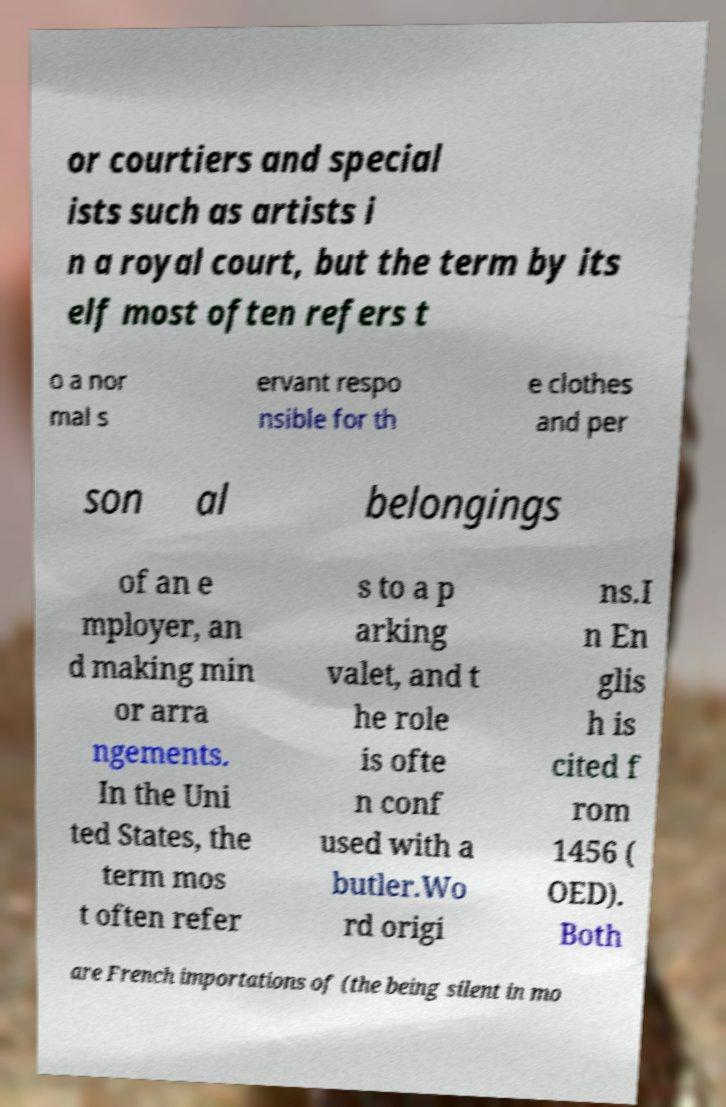Please identify and transcribe the text found in this image. or courtiers and special ists such as artists i n a royal court, but the term by its elf most often refers t o a nor mal s ervant respo nsible for th e clothes and per son al belongings of an e mployer, an d making min or arra ngements. In the Uni ted States, the term mos t often refer s to a p arking valet, and t he role is ofte n conf used with a butler.Wo rd origi ns.I n En glis h is cited f rom 1456 ( OED). Both are French importations of (the being silent in mo 